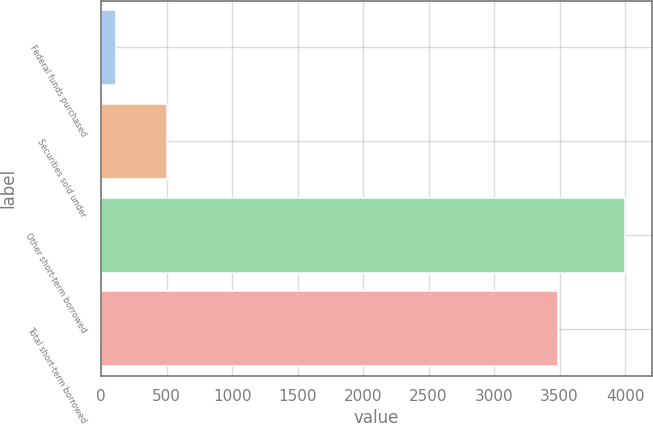<chart> <loc_0><loc_0><loc_500><loc_500><bar_chart><fcel>Federal funds purchased<fcel>Securities sold under<fcel>Other short-term borrowed<fcel>Total short-term borrowed<nl><fcel>115<fcel>503.7<fcel>4002<fcel>3487<nl></chart> 